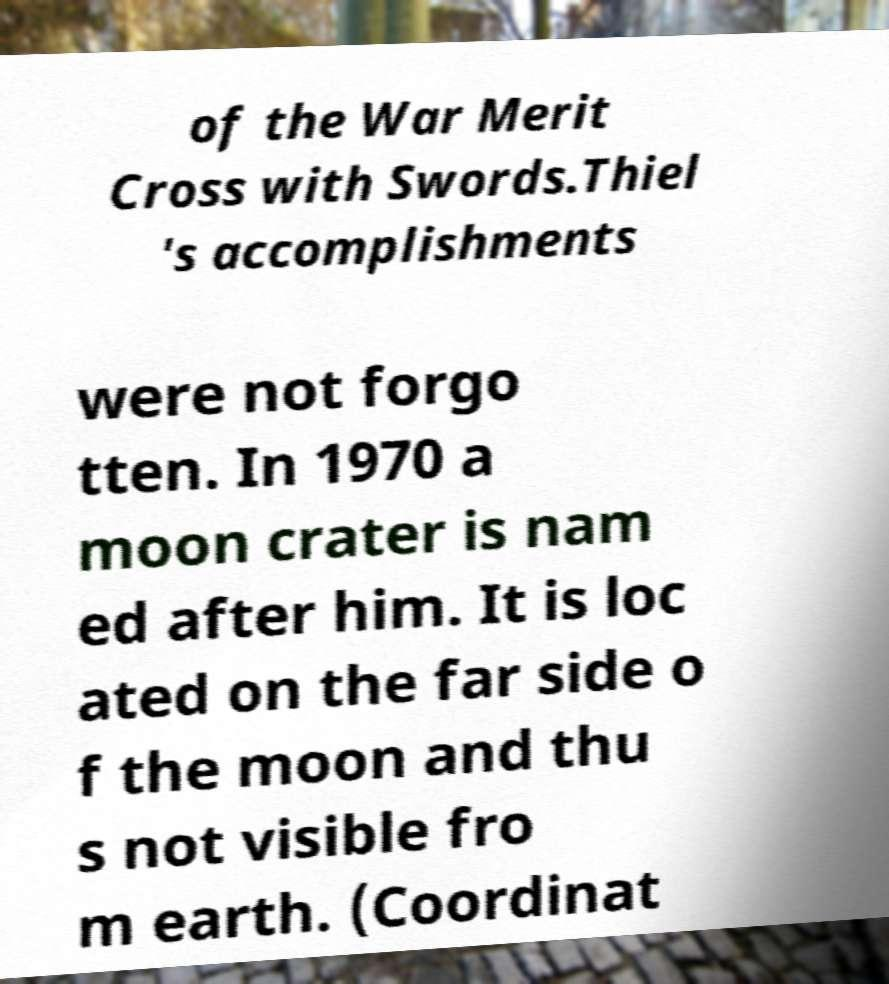I need the written content from this picture converted into text. Can you do that? of the War Merit Cross with Swords.Thiel 's accomplishments were not forgo tten. In 1970 a moon crater is nam ed after him. It is loc ated on the far side o f the moon and thu s not visible fro m earth. (Coordinat 